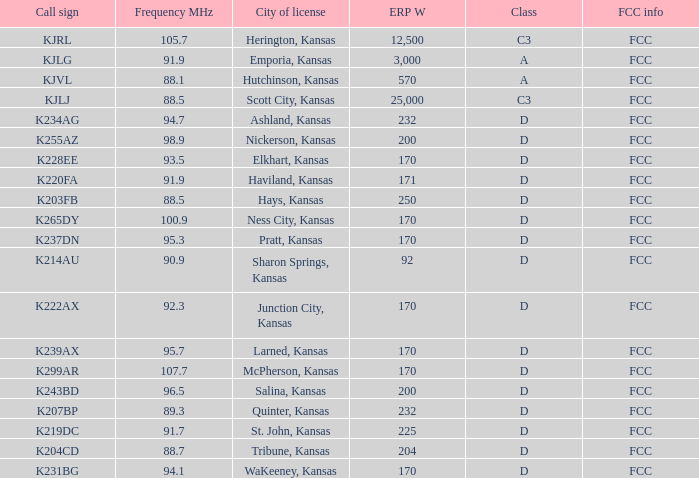3 and a call sign of k234ag, which class is it? D. 